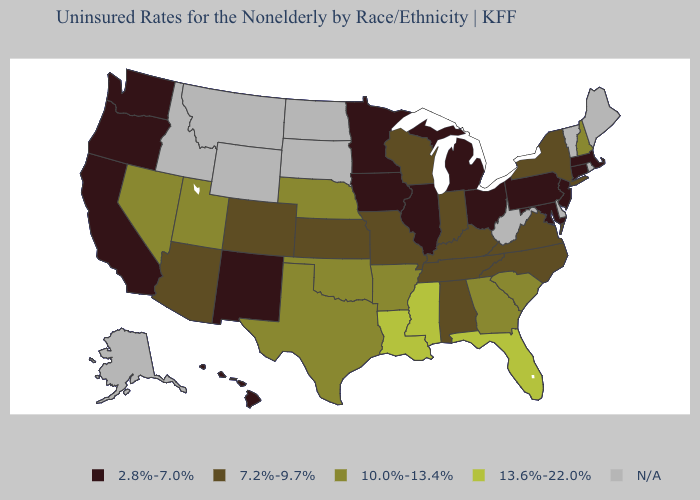Does New York have the lowest value in the Northeast?
Give a very brief answer. No. Among the states that border New Mexico , which have the highest value?
Concise answer only. Oklahoma, Texas, Utah. Name the states that have a value in the range 7.2%-9.7%?
Give a very brief answer. Alabama, Arizona, Colorado, Indiana, Kansas, Kentucky, Missouri, New York, North Carolina, Tennessee, Virginia, Wisconsin. Name the states that have a value in the range 7.2%-9.7%?
Write a very short answer. Alabama, Arizona, Colorado, Indiana, Kansas, Kentucky, Missouri, New York, North Carolina, Tennessee, Virginia, Wisconsin. Among the states that border Iowa , which have the lowest value?
Short answer required. Illinois, Minnesota. Which states hav the highest value in the MidWest?
Answer briefly. Nebraska. Which states have the highest value in the USA?
Write a very short answer. Florida, Louisiana, Mississippi. What is the lowest value in the USA?
Keep it brief. 2.8%-7.0%. What is the value of New Mexico?
Concise answer only. 2.8%-7.0%. What is the value of Massachusetts?
Answer briefly. 2.8%-7.0%. What is the highest value in the Northeast ?
Keep it brief. 10.0%-13.4%. Name the states that have a value in the range N/A?
Short answer required. Alaska, Delaware, Idaho, Maine, Montana, North Dakota, Rhode Island, South Dakota, Vermont, West Virginia, Wyoming. What is the highest value in the USA?
Answer briefly. 13.6%-22.0%. 